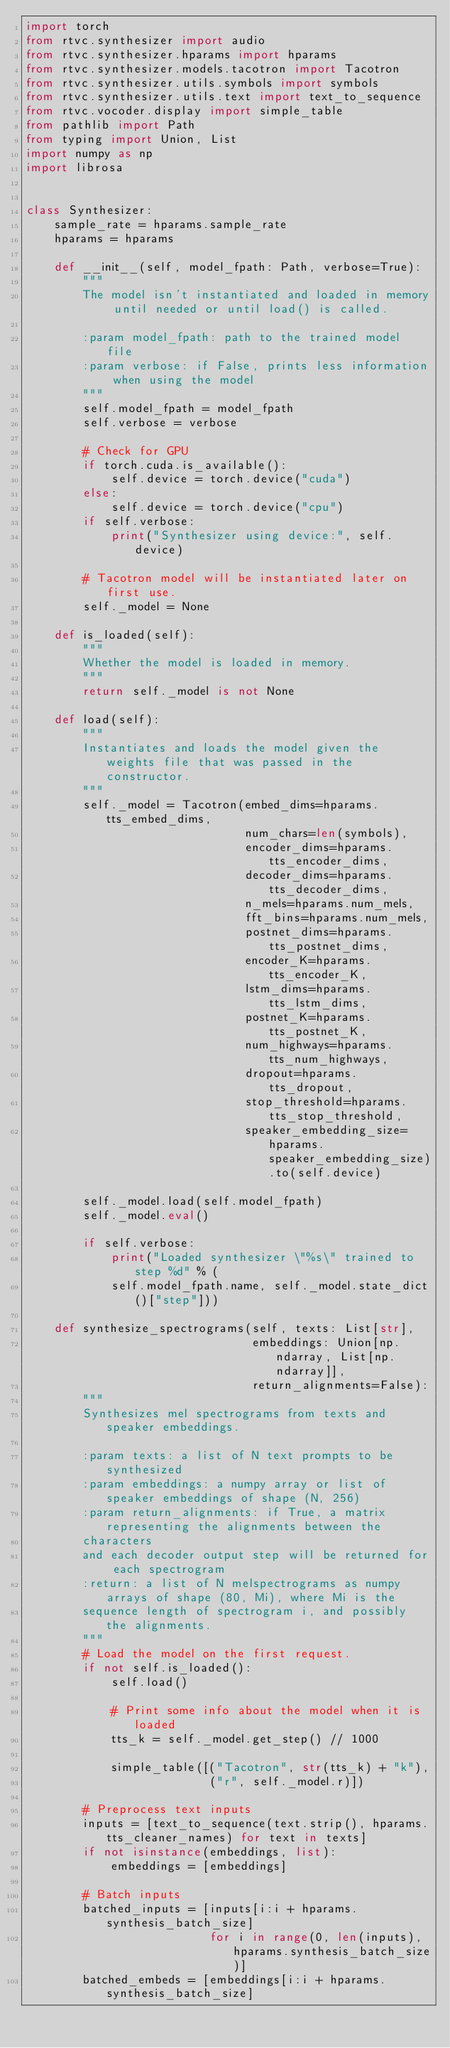<code> <loc_0><loc_0><loc_500><loc_500><_Python_>import torch
from rtvc.synthesizer import audio
from rtvc.synthesizer.hparams import hparams
from rtvc.synthesizer.models.tacotron import Tacotron
from rtvc.synthesizer.utils.symbols import symbols
from rtvc.synthesizer.utils.text import text_to_sequence
from rtvc.vocoder.display import simple_table
from pathlib import Path
from typing import Union, List
import numpy as np
import librosa


class Synthesizer:
    sample_rate = hparams.sample_rate
    hparams = hparams

    def __init__(self, model_fpath: Path, verbose=True):
        """
        The model isn't instantiated and loaded in memory until needed or until load() is called.
        
        :param model_fpath: path to the trained model file
        :param verbose: if False, prints less information when using the model
        """
        self.model_fpath = model_fpath
        self.verbose = verbose

        # Check for GPU
        if torch.cuda.is_available():
            self.device = torch.device("cuda")
        else:
            self.device = torch.device("cpu")
        if self.verbose:
            print("Synthesizer using device:", self.device)

        # Tacotron model will be instantiated later on first use.
        self._model = None

    def is_loaded(self):
        """
        Whether the model is loaded in memory.
        """
        return self._model is not None

    def load(self):
        """
        Instantiates and loads the model given the weights file that was passed in the constructor.
        """
        self._model = Tacotron(embed_dims=hparams.tts_embed_dims,
                               num_chars=len(symbols),
                               encoder_dims=hparams.tts_encoder_dims,
                               decoder_dims=hparams.tts_decoder_dims,
                               n_mels=hparams.num_mels,
                               fft_bins=hparams.num_mels,
                               postnet_dims=hparams.tts_postnet_dims,
                               encoder_K=hparams.tts_encoder_K,
                               lstm_dims=hparams.tts_lstm_dims,
                               postnet_K=hparams.tts_postnet_K,
                               num_highways=hparams.tts_num_highways,
                               dropout=hparams.tts_dropout,
                               stop_threshold=hparams.tts_stop_threshold,
                               speaker_embedding_size=hparams.speaker_embedding_size).to(self.device)

        self._model.load(self.model_fpath)
        self._model.eval()

        if self.verbose:
            print("Loaded synthesizer \"%s\" trained to step %d" % (
            self.model_fpath.name, self._model.state_dict()["step"]))

    def synthesize_spectrograms(self, texts: List[str],
                                embeddings: Union[np.ndarray, List[np.ndarray]],
                                return_alignments=False):
        """
        Synthesizes mel spectrograms from texts and speaker embeddings.

        :param texts: a list of N text prompts to be synthesized
        :param embeddings: a numpy array or list of speaker embeddings of shape (N, 256) 
        :param return_alignments: if True, a matrix representing the alignments between the 
        characters
        and each decoder output step will be returned for each spectrogram
        :return: a list of N melspectrograms as numpy arrays of shape (80, Mi), where Mi is the 
        sequence length of spectrogram i, and possibly the alignments.
        """
        # Load the model on the first request.
        if not self.is_loaded():
            self.load()

            # Print some info about the model when it is loaded            
            tts_k = self._model.get_step() // 1000

            simple_table([("Tacotron", str(tts_k) + "k"),
                          ("r", self._model.r)])

        # Preprocess text inputs
        inputs = [text_to_sequence(text.strip(), hparams.tts_cleaner_names) for text in texts]
        if not isinstance(embeddings, list):
            embeddings = [embeddings]

        # Batch inputs
        batched_inputs = [inputs[i:i + hparams.synthesis_batch_size]
                          for i in range(0, len(inputs), hparams.synthesis_batch_size)]
        batched_embeds = [embeddings[i:i + hparams.synthesis_batch_size]</code> 